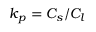<formula> <loc_0><loc_0><loc_500><loc_500>k _ { p } = C _ { s } / C _ { l }</formula> 